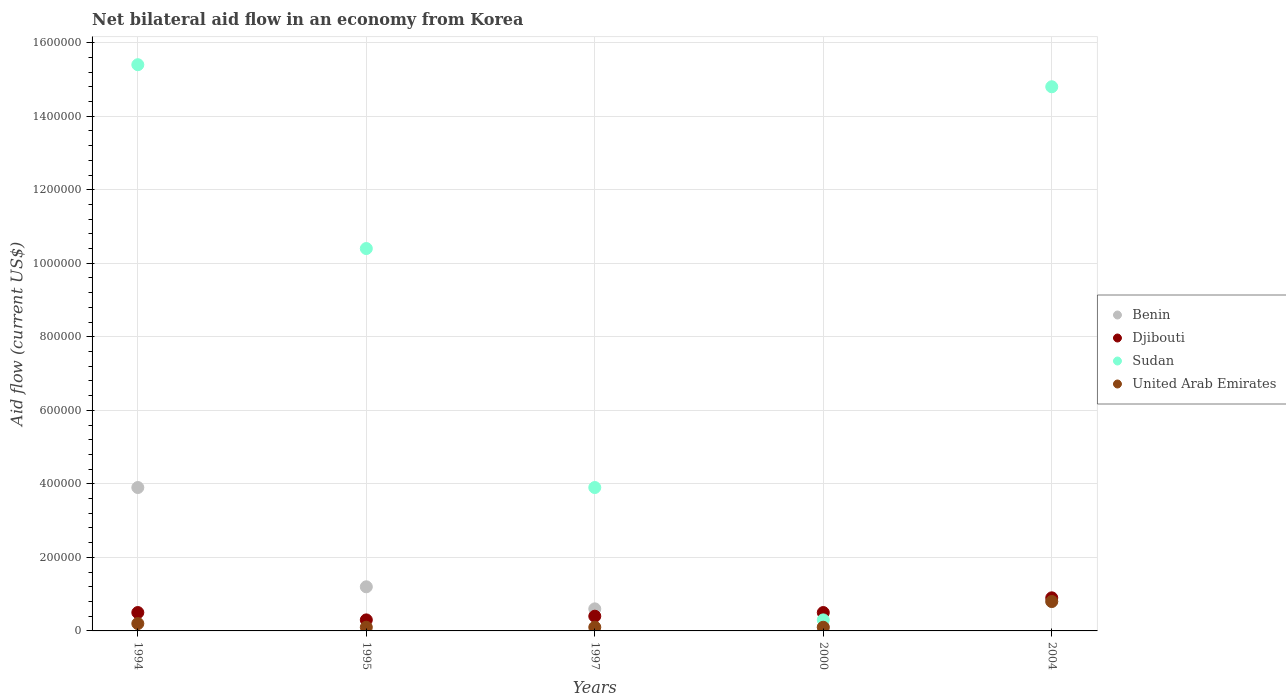Across all years, what is the maximum net bilateral aid flow in Benin?
Offer a very short reply. 3.90e+05. Across all years, what is the minimum net bilateral aid flow in Benin?
Offer a terse response. 10000. In which year was the net bilateral aid flow in United Arab Emirates maximum?
Your answer should be compact. 2004. What is the total net bilateral aid flow in Djibouti in the graph?
Provide a succinct answer. 2.60e+05. What is the average net bilateral aid flow in Sudan per year?
Offer a terse response. 8.96e+05. In how many years, is the net bilateral aid flow in Benin greater than 280000 US$?
Offer a very short reply. 1. What is the ratio of the net bilateral aid flow in Sudan in 1995 to that in 2000?
Offer a very short reply. 34.67. What is the difference between the highest and the lowest net bilateral aid flow in Djibouti?
Keep it short and to the point. 6.00e+04. In how many years, is the net bilateral aid flow in Benin greater than the average net bilateral aid flow in Benin taken over all years?
Your answer should be compact. 1. Is it the case that in every year, the sum of the net bilateral aid flow in Benin and net bilateral aid flow in United Arab Emirates  is greater than the sum of net bilateral aid flow in Djibouti and net bilateral aid flow in Sudan?
Your response must be concise. No. Is the net bilateral aid flow in Djibouti strictly greater than the net bilateral aid flow in Sudan over the years?
Ensure brevity in your answer.  No. How many years are there in the graph?
Make the answer very short. 5. Are the values on the major ticks of Y-axis written in scientific E-notation?
Provide a succinct answer. No. What is the title of the graph?
Offer a very short reply. Net bilateral aid flow in an economy from Korea. What is the Aid flow (current US$) of Sudan in 1994?
Provide a succinct answer. 1.54e+06. What is the Aid flow (current US$) in United Arab Emirates in 1994?
Your answer should be very brief. 2.00e+04. What is the Aid flow (current US$) in Sudan in 1995?
Ensure brevity in your answer.  1.04e+06. What is the Aid flow (current US$) in Sudan in 1997?
Your answer should be compact. 3.90e+05. What is the Aid flow (current US$) in United Arab Emirates in 1997?
Offer a very short reply. 10000. What is the Aid flow (current US$) of Djibouti in 2000?
Ensure brevity in your answer.  5.00e+04. What is the Aid flow (current US$) of Sudan in 2000?
Give a very brief answer. 3.00e+04. What is the Aid flow (current US$) of Benin in 2004?
Your answer should be very brief. 8.00e+04. What is the Aid flow (current US$) of Sudan in 2004?
Your answer should be compact. 1.48e+06. What is the Aid flow (current US$) in United Arab Emirates in 2004?
Provide a short and direct response. 8.00e+04. Across all years, what is the maximum Aid flow (current US$) of Benin?
Ensure brevity in your answer.  3.90e+05. Across all years, what is the maximum Aid flow (current US$) in Djibouti?
Offer a very short reply. 9.00e+04. Across all years, what is the maximum Aid flow (current US$) in Sudan?
Ensure brevity in your answer.  1.54e+06. Across all years, what is the minimum Aid flow (current US$) in Sudan?
Provide a succinct answer. 3.00e+04. What is the total Aid flow (current US$) in Benin in the graph?
Offer a very short reply. 6.60e+05. What is the total Aid flow (current US$) in Djibouti in the graph?
Offer a terse response. 2.60e+05. What is the total Aid flow (current US$) in Sudan in the graph?
Your response must be concise. 4.48e+06. What is the total Aid flow (current US$) in United Arab Emirates in the graph?
Your answer should be very brief. 1.30e+05. What is the difference between the Aid flow (current US$) of Benin in 1994 and that in 1995?
Provide a short and direct response. 2.70e+05. What is the difference between the Aid flow (current US$) of Benin in 1994 and that in 1997?
Offer a very short reply. 3.30e+05. What is the difference between the Aid flow (current US$) in Sudan in 1994 and that in 1997?
Your response must be concise. 1.15e+06. What is the difference between the Aid flow (current US$) of Djibouti in 1994 and that in 2000?
Offer a very short reply. 0. What is the difference between the Aid flow (current US$) of Sudan in 1994 and that in 2000?
Your answer should be very brief. 1.51e+06. What is the difference between the Aid flow (current US$) of United Arab Emirates in 1994 and that in 2000?
Offer a very short reply. 10000. What is the difference between the Aid flow (current US$) in Benin in 1994 and that in 2004?
Provide a short and direct response. 3.10e+05. What is the difference between the Aid flow (current US$) in Djibouti in 1994 and that in 2004?
Make the answer very short. -4.00e+04. What is the difference between the Aid flow (current US$) of United Arab Emirates in 1994 and that in 2004?
Give a very brief answer. -6.00e+04. What is the difference between the Aid flow (current US$) of Djibouti in 1995 and that in 1997?
Keep it short and to the point. -10000. What is the difference between the Aid flow (current US$) in Sudan in 1995 and that in 1997?
Offer a terse response. 6.50e+05. What is the difference between the Aid flow (current US$) of Benin in 1995 and that in 2000?
Your answer should be very brief. 1.10e+05. What is the difference between the Aid flow (current US$) of Djibouti in 1995 and that in 2000?
Your response must be concise. -2.00e+04. What is the difference between the Aid flow (current US$) in Sudan in 1995 and that in 2000?
Keep it short and to the point. 1.01e+06. What is the difference between the Aid flow (current US$) of United Arab Emirates in 1995 and that in 2000?
Ensure brevity in your answer.  0. What is the difference between the Aid flow (current US$) in Benin in 1995 and that in 2004?
Ensure brevity in your answer.  4.00e+04. What is the difference between the Aid flow (current US$) in Sudan in 1995 and that in 2004?
Offer a terse response. -4.40e+05. What is the difference between the Aid flow (current US$) in Benin in 1997 and that in 2004?
Provide a short and direct response. -2.00e+04. What is the difference between the Aid flow (current US$) of Sudan in 1997 and that in 2004?
Keep it short and to the point. -1.09e+06. What is the difference between the Aid flow (current US$) of Sudan in 2000 and that in 2004?
Your answer should be very brief. -1.45e+06. What is the difference between the Aid flow (current US$) of Benin in 1994 and the Aid flow (current US$) of Sudan in 1995?
Offer a very short reply. -6.50e+05. What is the difference between the Aid flow (current US$) of Djibouti in 1994 and the Aid flow (current US$) of Sudan in 1995?
Ensure brevity in your answer.  -9.90e+05. What is the difference between the Aid flow (current US$) in Djibouti in 1994 and the Aid flow (current US$) in United Arab Emirates in 1995?
Ensure brevity in your answer.  4.00e+04. What is the difference between the Aid flow (current US$) in Sudan in 1994 and the Aid flow (current US$) in United Arab Emirates in 1995?
Provide a short and direct response. 1.53e+06. What is the difference between the Aid flow (current US$) in Benin in 1994 and the Aid flow (current US$) in Djibouti in 1997?
Provide a short and direct response. 3.50e+05. What is the difference between the Aid flow (current US$) of Sudan in 1994 and the Aid flow (current US$) of United Arab Emirates in 1997?
Make the answer very short. 1.53e+06. What is the difference between the Aid flow (current US$) of Benin in 1994 and the Aid flow (current US$) of Djibouti in 2000?
Offer a terse response. 3.40e+05. What is the difference between the Aid flow (current US$) in Djibouti in 1994 and the Aid flow (current US$) in United Arab Emirates in 2000?
Your answer should be compact. 4.00e+04. What is the difference between the Aid flow (current US$) in Sudan in 1994 and the Aid flow (current US$) in United Arab Emirates in 2000?
Your answer should be compact. 1.53e+06. What is the difference between the Aid flow (current US$) of Benin in 1994 and the Aid flow (current US$) of Djibouti in 2004?
Your answer should be compact. 3.00e+05. What is the difference between the Aid flow (current US$) of Benin in 1994 and the Aid flow (current US$) of Sudan in 2004?
Provide a short and direct response. -1.09e+06. What is the difference between the Aid flow (current US$) of Benin in 1994 and the Aid flow (current US$) of United Arab Emirates in 2004?
Give a very brief answer. 3.10e+05. What is the difference between the Aid flow (current US$) of Djibouti in 1994 and the Aid flow (current US$) of Sudan in 2004?
Your answer should be very brief. -1.43e+06. What is the difference between the Aid flow (current US$) of Djibouti in 1994 and the Aid flow (current US$) of United Arab Emirates in 2004?
Make the answer very short. -3.00e+04. What is the difference between the Aid flow (current US$) of Sudan in 1994 and the Aid flow (current US$) of United Arab Emirates in 2004?
Keep it short and to the point. 1.46e+06. What is the difference between the Aid flow (current US$) of Benin in 1995 and the Aid flow (current US$) of Djibouti in 1997?
Provide a succinct answer. 8.00e+04. What is the difference between the Aid flow (current US$) of Djibouti in 1995 and the Aid flow (current US$) of Sudan in 1997?
Make the answer very short. -3.60e+05. What is the difference between the Aid flow (current US$) of Sudan in 1995 and the Aid flow (current US$) of United Arab Emirates in 1997?
Make the answer very short. 1.03e+06. What is the difference between the Aid flow (current US$) in Benin in 1995 and the Aid flow (current US$) in Djibouti in 2000?
Ensure brevity in your answer.  7.00e+04. What is the difference between the Aid flow (current US$) of Djibouti in 1995 and the Aid flow (current US$) of Sudan in 2000?
Make the answer very short. 0. What is the difference between the Aid flow (current US$) in Sudan in 1995 and the Aid flow (current US$) in United Arab Emirates in 2000?
Ensure brevity in your answer.  1.03e+06. What is the difference between the Aid flow (current US$) in Benin in 1995 and the Aid flow (current US$) in Djibouti in 2004?
Provide a short and direct response. 3.00e+04. What is the difference between the Aid flow (current US$) of Benin in 1995 and the Aid flow (current US$) of Sudan in 2004?
Provide a short and direct response. -1.36e+06. What is the difference between the Aid flow (current US$) of Djibouti in 1995 and the Aid flow (current US$) of Sudan in 2004?
Provide a succinct answer. -1.45e+06. What is the difference between the Aid flow (current US$) of Sudan in 1995 and the Aid flow (current US$) of United Arab Emirates in 2004?
Make the answer very short. 9.60e+05. What is the difference between the Aid flow (current US$) of Benin in 1997 and the Aid flow (current US$) of Djibouti in 2000?
Make the answer very short. 10000. What is the difference between the Aid flow (current US$) in Benin in 1997 and the Aid flow (current US$) in Sudan in 2000?
Give a very brief answer. 3.00e+04. What is the difference between the Aid flow (current US$) in Benin in 1997 and the Aid flow (current US$) in Djibouti in 2004?
Provide a succinct answer. -3.00e+04. What is the difference between the Aid flow (current US$) of Benin in 1997 and the Aid flow (current US$) of Sudan in 2004?
Your answer should be compact. -1.42e+06. What is the difference between the Aid flow (current US$) in Djibouti in 1997 and the Aid flow (current US$) in Sudan in 2004?
Your answer should be compact. -1.44e+06. What is the difference between the Aid flow (current US$) in Benin in 2000 and the Aid flow (current US$) in Sudan in 2004?
Keep it short and to the point. -1.47e+06. What is the difference between the Aid flow (current US$) in Djibouti in 2000 and the Aid flow (current US$) in Sudan in 2004?
Give a very brief answer. -1.43e+06. What is the average Aid flow (current US$) of Benin per year?
Provide a succinct answer. 1.32e+05. What is the average Aid flow (current US$) in Djibouti per year?
Ensure brevity in your answer.  5.20e+04. What is the average Aid flow (current US$) in Sudan per year?
Offer a very short reply. 8.96e+05. What is the average Aid flow (current US$) of United Arab Emirates per year?
Provide a succinct answer. 2.60e+04. In the year 1994, what is the difference between the Aid flow (current US$) in Benin and Aid flow (current US$) in Sudan?
Offer a very short reply. -1.15e+06. In the year 1994, what is the difference between the Aid flow (current US$) in Benin and Aid flow (current US$) in United Arab Emirates?
Give a very brief answer. 3.70e+05. In the year 1994, what is the difference between the Aid flow (current US$) of Djibouti and Aid flow (current US$) of Sudan?
Your response must be concise. -1.49e+06. In the year 1994, what is the difference between the Aid flow (current US$) in Sudan and Aid flow (current US$) in United Arab Emirates?
Your answer should be very brief. 1.52e+06. In the year 1995, what is the difference between the Aid flow (current US$) of Benin and Aid flow (current US$) of Sudan?
Keep it short and to the point. -9.20e+05. In the year 1995, what is the difference between the Aid flow (current US$) of Benin and Aid flow (current US$) of United Arab Emirates?
Give a very brief answer. 1.10e+05. In the year 1995, what is the difference between the Aid flow (current US$) in Djibouti and Aid flow (current US$) in Sudan?
Your answer should be very brief. -1.01e+06. In the year 1995, what is the difference between the Aid flow (current US$) in Djibouti and Aid flow (current US$) in United Arab Emirates?
Give a very brief answer. 2.00e+04. In the year 1995, what is the difference between the Aid flow (current US$) in Sudan and Aid flow (current US$) in United Arab Emirates?
Make the answer very short. 1.03e+06. In the year 1997, what is the difference between the Aid flow (current US$) in Benin and Aid flow (current US$) in Sudan?
Ensure brevity in your answer.  -3.30e+05. In the year 1997, what is the difference between the Aid flow (current US$) in Djibouti and Aid flow (current US$) in Sudan?
Make the answer very short. -3.50e+05. In the year 1997, what is the difference between the Aid flow (current US$) in Sudan and Aid flow (current US$) in United Arab Emirates?
Your response must be concise. 3.80e+05. In the year 2000, what is the difference between the Aid flow (current US$) of Benin and Aid flow (current US$) of Djibouti?
Provide a succinct answer. -4.00e+04. In the year 2000, what is the difference between the Aid flow (current US$) in Benin and Aid flow (current US$) in Sudan?
Offer a terse response. -2.00e+04. In the year 2000, what is the difference between the Aid flow (current US$) of Djibouti and Aid flow (current US$) of United Arab Emirates?
Make the answer very short. 4.00e+04. In the year 2004, what is the difference between the Aid flow (current US$) of Benin and Aid flow (current US$) of Djibouti?
Ensure brevity in your answer.  -10000. In the year 2004, what is the difference between the Aid flow (current US$) in Benin and Aid flow (current US$) in Sudan?
Provide a succinct answer. -1.40e+06. In the year 2004, what is the difference between the Aid flow (current US$) of Djibouti and Aid flow (current US$) of Sudan?
Keep it short and to the point. -1.39e+06. In the year 2004, what is the difference between the Aid flow (current US$) of Djibouti and Aid flow (current US$) of United Arab Emirates?
Provide a succinct answer. 10000. In the year 2004, what is the difference between the Aid flow (current US$) in Sudan and Aid flow (current US$) in United Arab Emirates?
Provide a succinct answer. 1.40e+06. What is the ratio of the Aid flow (current US$) in Djibouti in 1994 to that in 1995?
Keep it short and to the point. 1.67. What is the ratio of the Aid flow (current US$) of Sudan in 1994 to that in 1995?
Give a very brief answer. 1.48. What is the ratio of the Aid flow (current US$) in Benin in 1994 to that in 1997?
Your response must be concise. 6.5. What is the ratio of the Aid flow (current US$) in Djibouti in 1994 to that in 1997?
Offer a very short reply. 1.25. What is the ratio of the Aid flow (current US$) in Sudan in 1994 to that in 1997?
Keep it short and to the point. 3.95. What is the ratio of the Aid flow (current US$) of United Arab Emirates in 1994 to that in 1997?
Offer a very short reply. 2. What is the ratio of the Aid flow (current US$) of Benin in 1994 to that in 2000?
Make the answer very short. 39. What is the ratio of the Aid flow (current US$) of Djibouti in 1994 to that in 2000?
Offer a very short reply. 1. What is the ratio of the Aid flow (current US$) in Sudan in 1994 to that in 2000?
Provide a succinct answer. 51.33. What is the ratio of the Aid flow (current US$) of Benin in 1994 to that in 2004?
Your response must be concise. 4.88. What is the ratio of the Aid flow (current US$) in Djibouti in 1994 to that in 2004?
Give a very brief answer. 0.56. What is the ratio of the Aid flow (current US$) in Sudan in 1994 to that in 2004?
Keep it short and to the point. 1.04. What is the ratio of the Aid flow (current US$) in Benin in 1995 to that in 1997?
Offer a terse response. 2. What is the ratio of the Aid flow (current US$) in Djibouti in 1995 to that in 1997?
Offer a terse response. 0.75. What is the ratio of the Aid flow (current US$) in Sudan in 1995 to that in 1997?
Your response must be concise. 2.67. What is the ratio of the Aid flow (current US$) in United Arab Emirates in 1995 to that in 1997?
Provide a short and direct response. 1. What is the ratio of the Aid flow (current US$) of Djibouti in 1995 to that in 2000?
Offer a very short reply. 0.6. What is the ratio of the Aid flow (current US$) in Sudan in 1995 to that in 2000?
Give a very brief answer. 34.67. What is the ratio of the Aid flow (current US$) in Sudan in 1995 to that in 2004?
Your response must be concise. 0.7. What is the ratio of the Aid flow (current US$) in United Arab Emirates in 1995 to that in 2004?
Your response must be concise. 0.12. What is the ratio of the Aid flow (current US$) of Djibouti in 1997 to that in 2000?
Give a very brief answer. 0.8. What is the ratio of the Aid flow (current US$) of United Arab Emirates in 1997 to that in 2000?
Keep it short and to the point. 1. What is the ratio of the Aid flow (current US$) of Benin in 1997 to that in 2004?
Offer a terse response. 0.75. What is the ratio of the Aid flow (current US$) in Djibouti in 1997 to that in 2004?
Provide a succinct answer. 0.44. What is the ratio of the Aid flow (current US$) in Sudan in 1997 to that in 2004?
Keep it short and to the point. 0.26. What is the ratio of the Aid flow (current US$) of United Arab Emirates in 1997 to that in 2004?
Provide a short and direct response. 0.12. What is the ratio of the Aid flow (current US$) of Benin in 2000 to that in 2004?
Provide a succinct answer. 0.12. What is the ratio of the Aid flow (current US$) of Djibouti in 2000 to that in 2004?
Offer a very short reply. 0.56. What is the ratio of the Aid flow (current US$) of Sudan in 2000 to that in 2004?
Provide a succinct answer. 0.02. What is the ratio of the Aid flow (current US$) in United Arab Emirates in 2000 to that in 2004?
Provide a succinct answer. 0.12. What is the difference between the highest and the second highest Aid flow (current US$) of Benin?
Your answer should be compact. 2.70e+05. What is the difference between the highest and the second highest Aid flow (current US$) in Djibouti?
Keep it short and to the point. 4.00e+04. What is the difference between the highest and the lowest Aid flow (current US$) in Djibouti?
Provide a succinct answer. 6.00e+04. What is the difference between the highest and the lowest Aid flow (current US$) of Sudan?
Your answer should be very brief. 1.51e+06. 